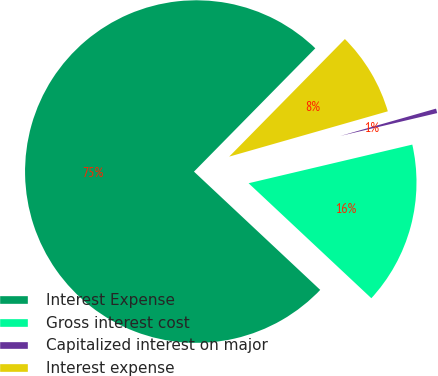Convert chart to OTSL. <chart><loc_0><loc_0><loc_500><loc_500><pie_chart><fcel>Interest Expense<fcel>Gross interest cost<fcel>Capitalized interest on major<fcel>Interest expense<nl><fcel>75.39%<fcel>15.67%<fcel>0.74%<fcel>8.2%<nl></chart> 